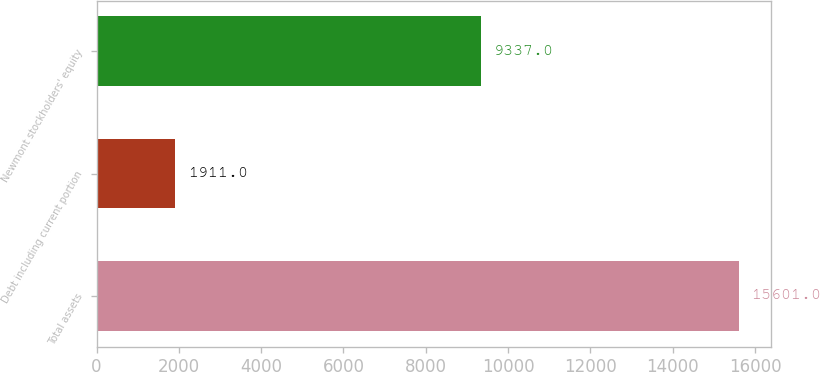Convert chart. <chart><loc_0><loc_0><loc_500><loc_500><bar_chart><fcel>Total assets<fcel>Debt including current portion<fcel>Newmont stockholders' equity<nl><fcel>15601<fcel>1911<fcel>9337<nl></chart> 